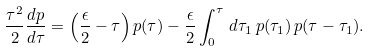<formula> <loc_0><loc_0><loc_500><loc_500>\frac { \tau ^ { 2 } } { 2 } \frac { d p } { d \tau } = \left ( \frac { \epsilon } { 2 } - \tau \right ) p ( \tau ) - \frac { \epsilon } { 2 } \int _ { 0 } ^ { \tau } \, d \tau _ { 1 } \, p ( \tau _ { 1 } ) \, p ( \tau - \tau _ { 1 } ) .</formula> 